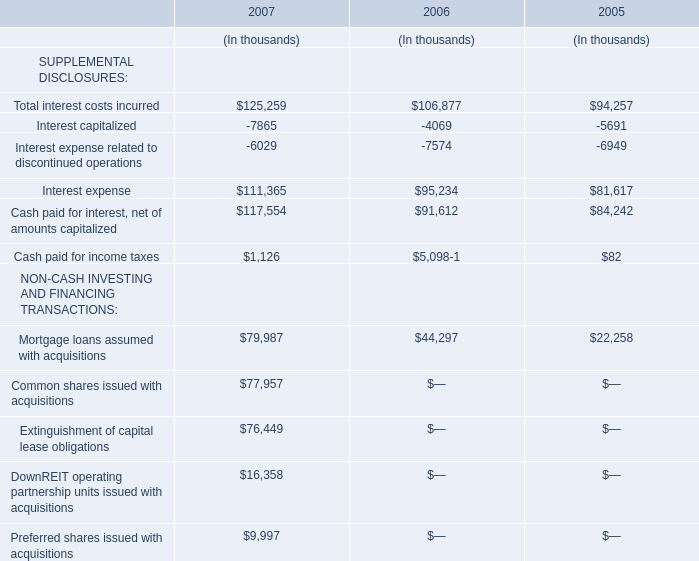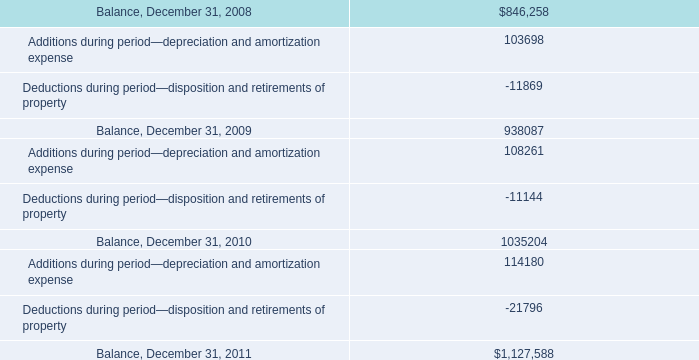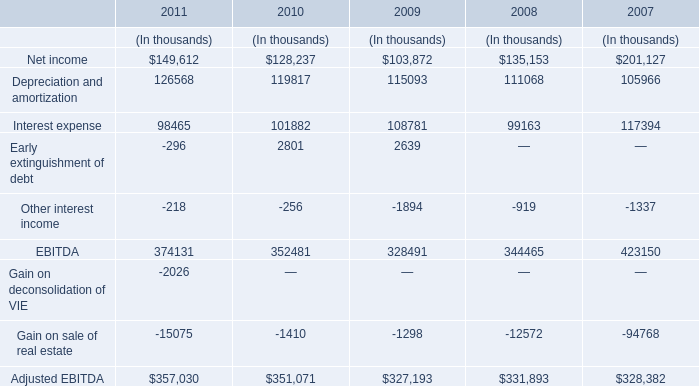what is the percentual growth of the depreciation and amortization expenses during 2008 and 2009? 
Computations: ((108261 / 103698) - 1)
Answer: 0.044. 